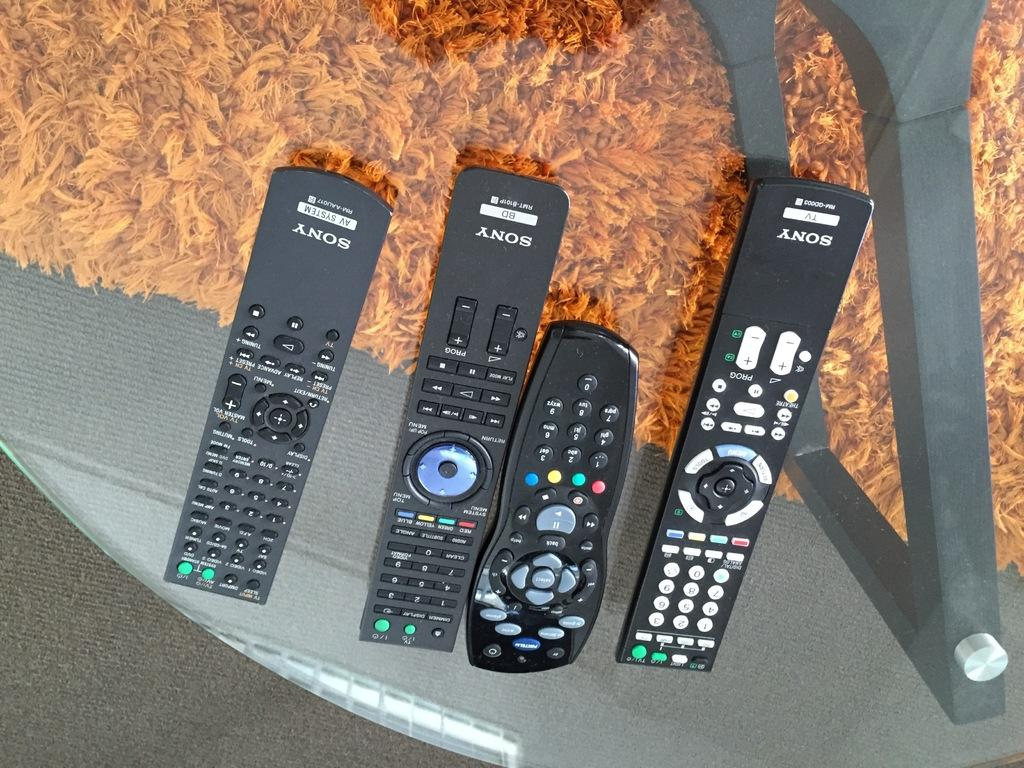<image>
Describe the image concisely. Four remotes on a table that are from the brand Sony. 